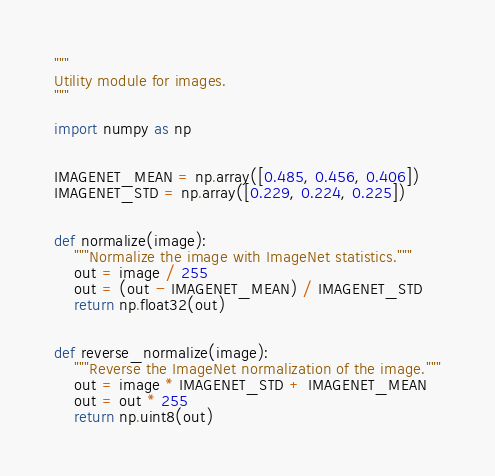Convert code to text. <code><loc_0><loc_0><loc_500><loc_500><_Python_>"""
Utility module for images.
"""

import numpy as np


IMAGENET_MEAN = np.array([0.485, 0.456, 0.406])
IMAGENET_STD = np.array([0.229, 0.224, 0.225])


def normalize(image):
    """Normalize the image with ImageNet statistics."""
    out = image / 255
    out = (out - IMAGENET_MEAN) / IMAGENET_STD
    return np.float32(out)


def reverse_normalize(image):
    """Reverse the ImageNet normalization of the image."""
    out = image * IMAGENET_STD + IMAGENET_MEAN
    out = out * 255
    return np.uint8(out)</code> 